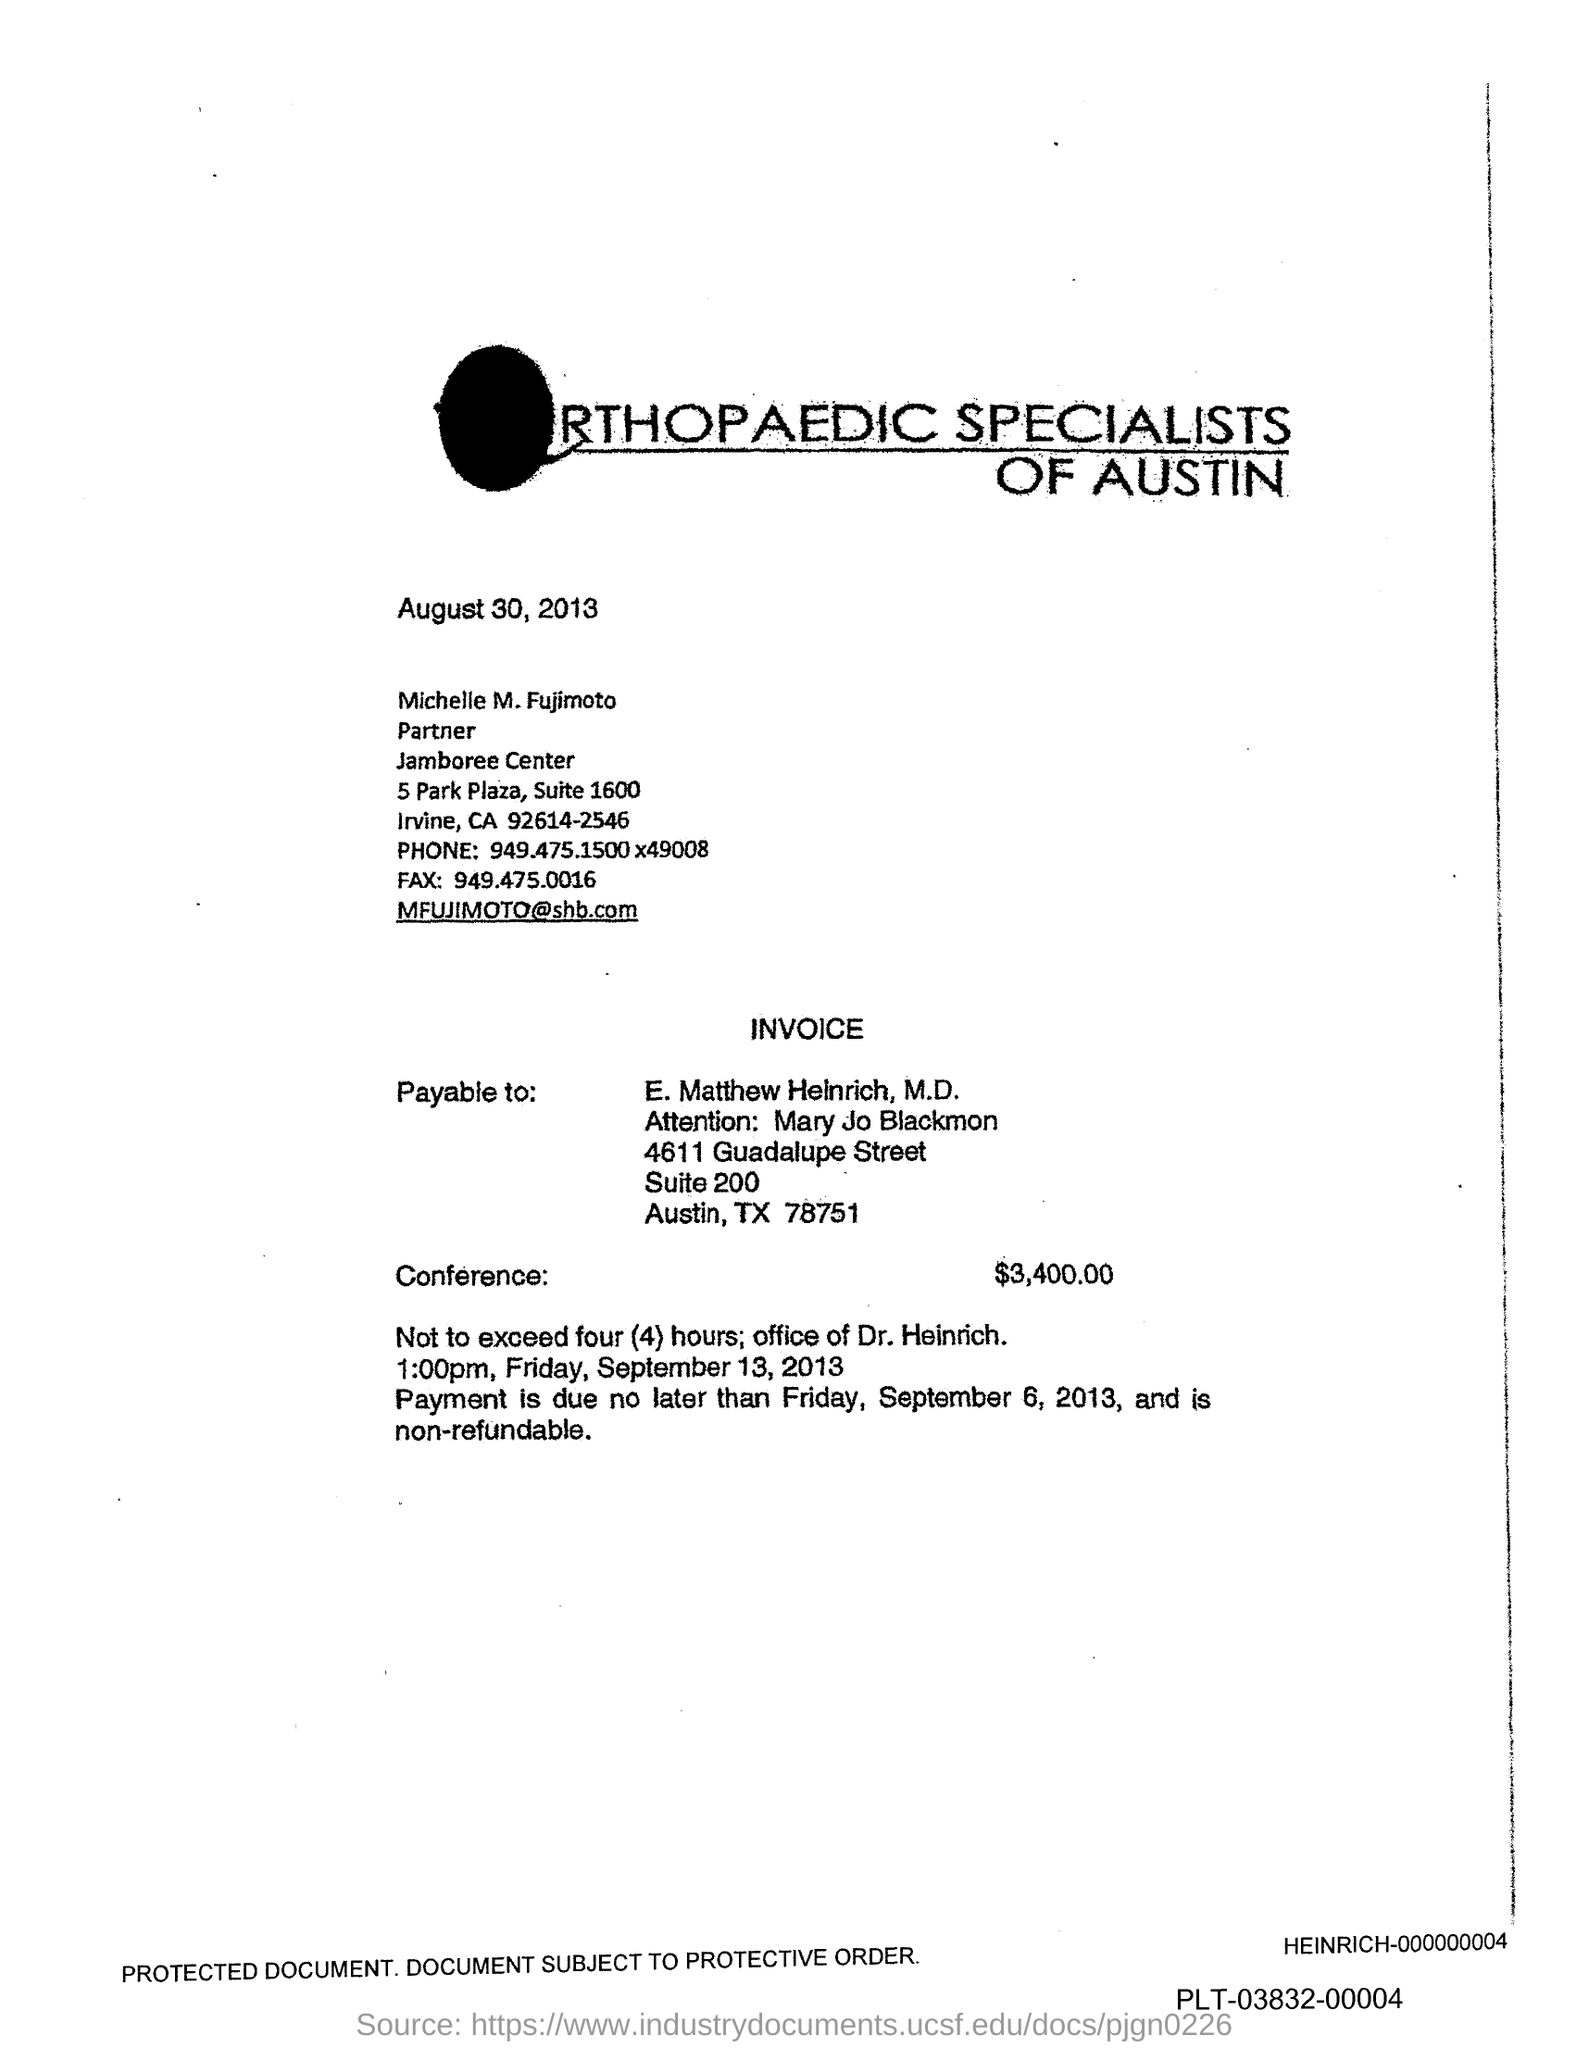Highlight a few significant elements in this photo. The fax number mentioned is 949.475.0016... Fujimoto's phone number is 949.475.1500x49008. The payment is due no later than Friday, September 6, 2013. The date mentioned at the top of the page is August 30, 2013. The conference amount is $3,400.00. 